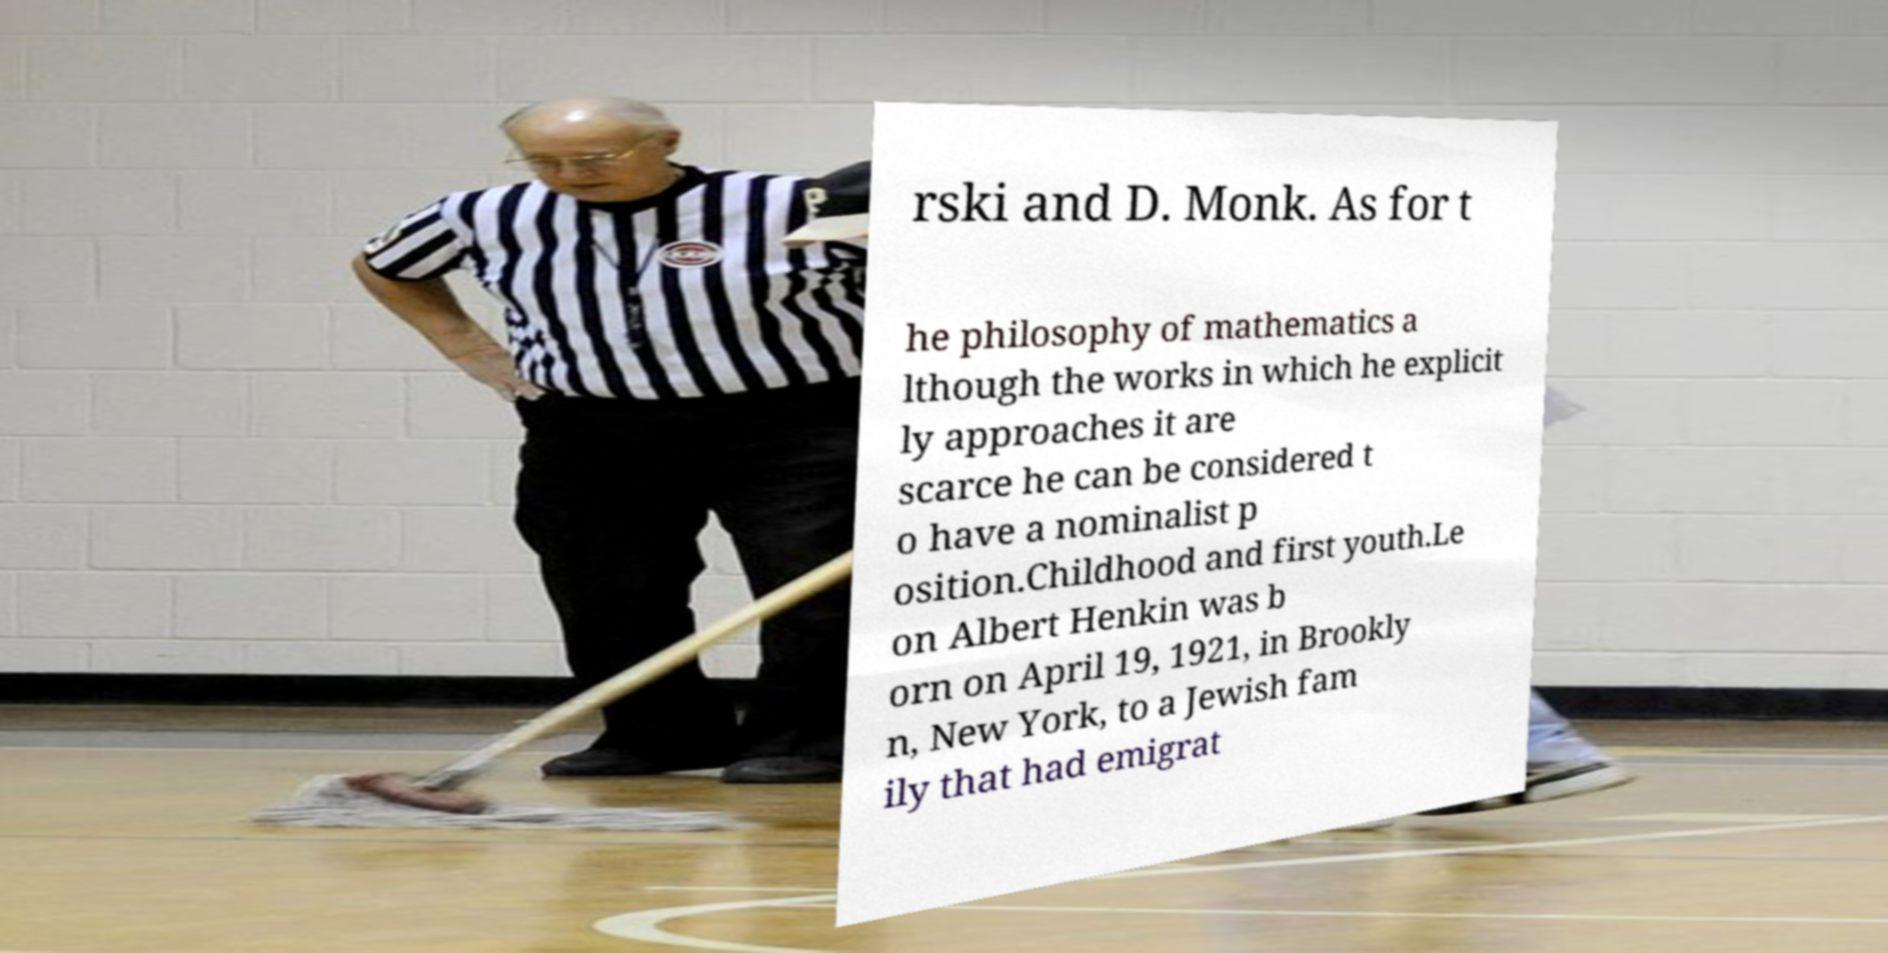Can you accurately transcribe the text from the provided image for me? rski and D. Monk. As for t he philosophy of mathematics a lthough the works in which he explicit ly approaches it are scarce he can be considered t o have a nominalist p osition.Childhood and first youth.Le on Albert Henkin was b orn on April 19, 1921, in Brookly n, New York, to a Jewish fam ily that had emigrat 